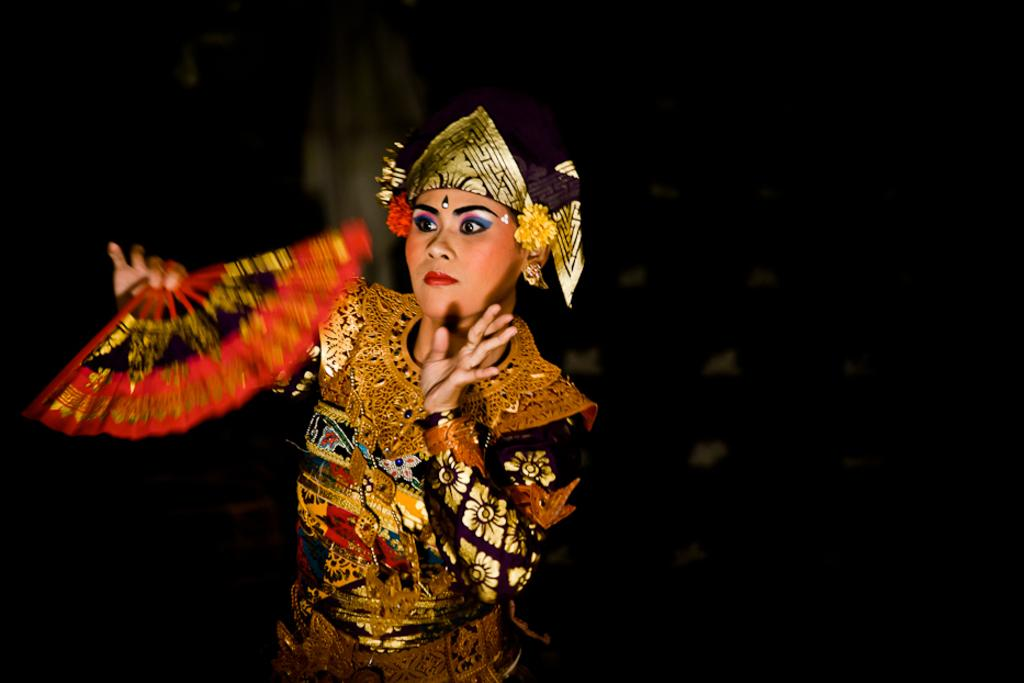Who is the main subject in the foreground of the image? There is a woman in the foreground of the image. What is the woman wearing? The woman is wearing a costume. What object is the woman holding in her hand? The woman is holding a folding fan in her hand. What can be observed about the background of the image? The background of the image is dark. What type of rake is being used to create the design on the woman's costume? There is no rake present in the image, nor is there any indication of a design being created on the woman's costume. 